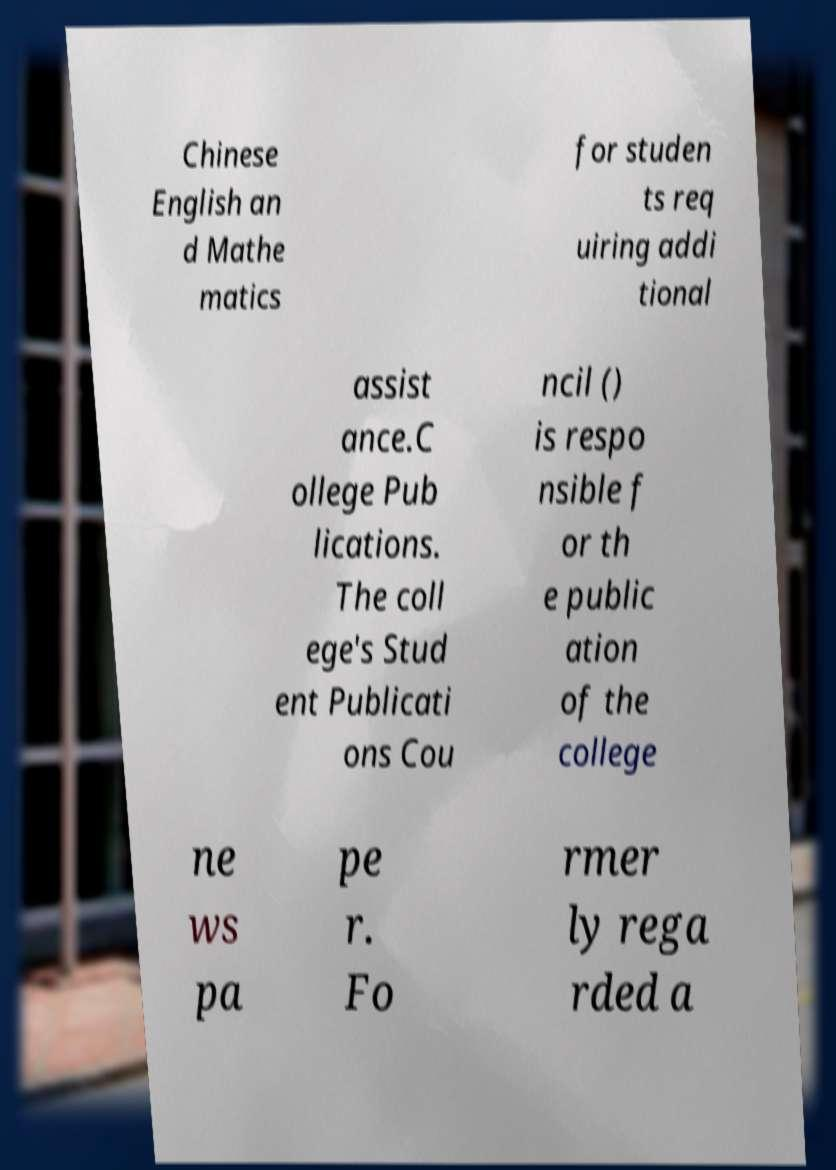Can you read and provide the text displayed in the image?This photo seems to have some interesting text. Can you extract and type it out for me? Chinese English an d Mathe matics for studen ts req uiring addi tional assist ance.C ollege Pub lications. The coll ege's Stud ent Publicati ons Cou ncil () is respo nsible f or th e public ation of the college ne ws pa pe r. Fo rmer ly rega rded a 